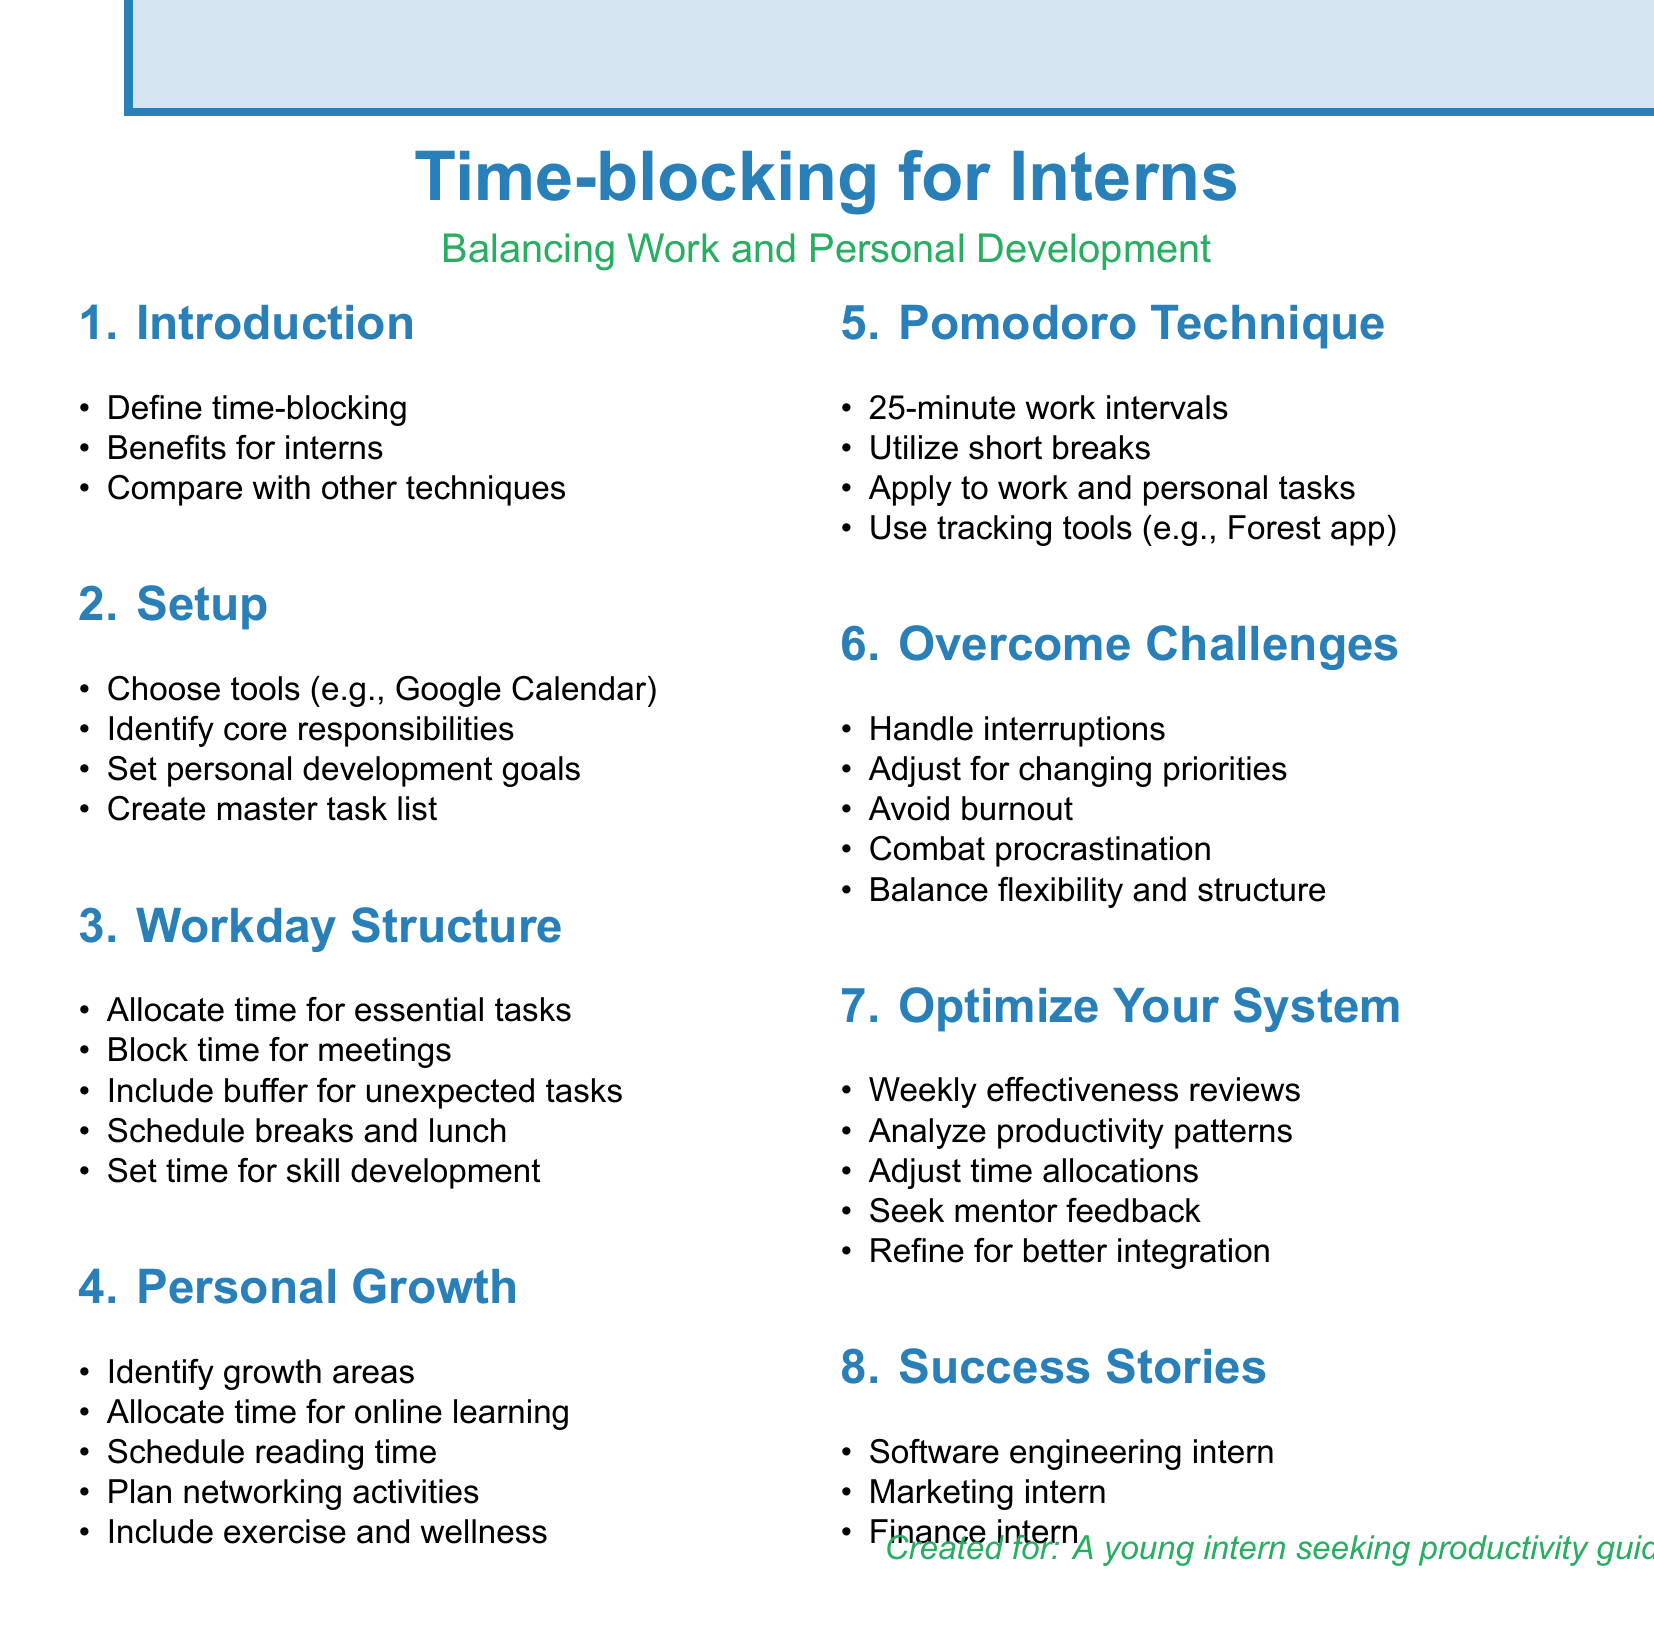What is the definition of time-blocking? The definition of time-blocking is outlined in the introduction section of the document.
Answer: Time-blocking Which tools are suggested for setting up a time-blocking system? The document lists several tools in the setup section that can help with time-blocking.
Answer: Google Calendar, Todoist, Notion How long is each work interval in the Pomodoro Technique? The specific duration of work intervals in the Pomodoro Technique is mentioned in its dedicated section.
Answer: 25 minutes What is one key area for growth mentioned in the personal development section? The personal growth section identifies areas where interns can focus on their development.
Answer: Programming skills What frequent activity is recommended to avoid burnout? The document discusses various strategies to manage productivity and avoid burnout.
Answer: Scheduling breaks How often should you conduct reviews of your time-blocking effectiveness? The review section specifies the frequency for evaluating your time-blocking system.
Answer: Weekly What type of feedback should you seek to improve your time-blocking system? The document emphasizes the importance of receiving feedback from a specific source to enhance time management.
Answer: Feedback from mentors or supervisors Which success story is mentioned related to a finance intern? A specific example in the success stories section highlights how a certain role balanced responsibilities.
Answer: Preparing for professional certifications What is one tool suggested for tracking Pomodoro sessions? The document provides examples of tools that can be utilized for tracking Pomodoro intervals.
Answer: Forest app 